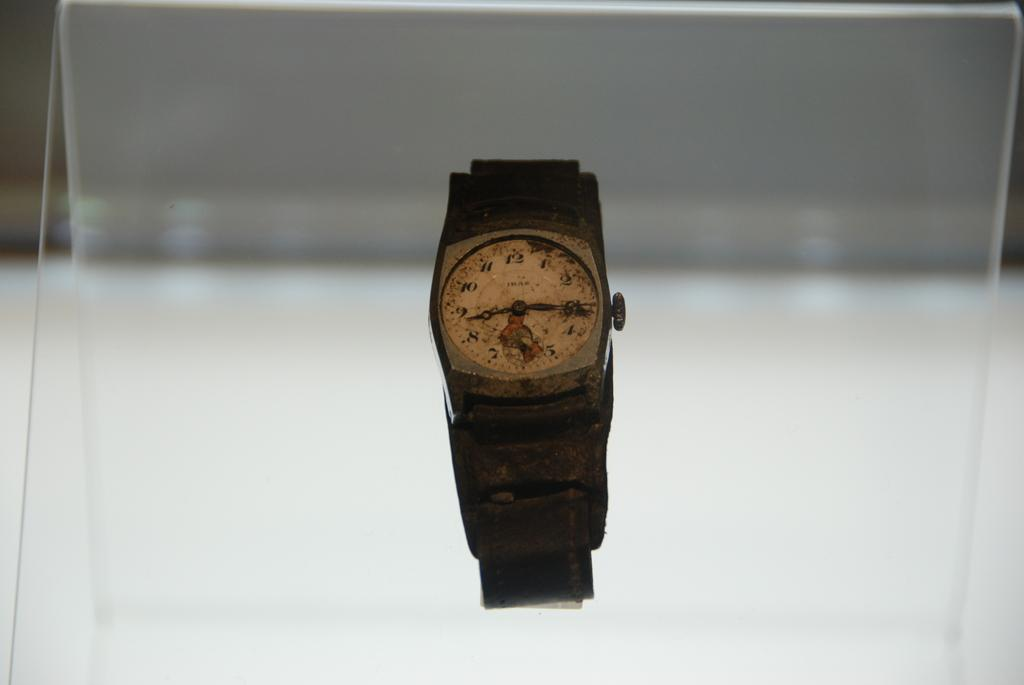What object is located in the foreground of the image? There is a watch in the foreground of the image. What other object can be seen in the image? There is a glass visible in the image. What type of dock can be seen in the image? There is no dock present in the image. How many elbows are visible in the image? There are no elbows visible in the image. 